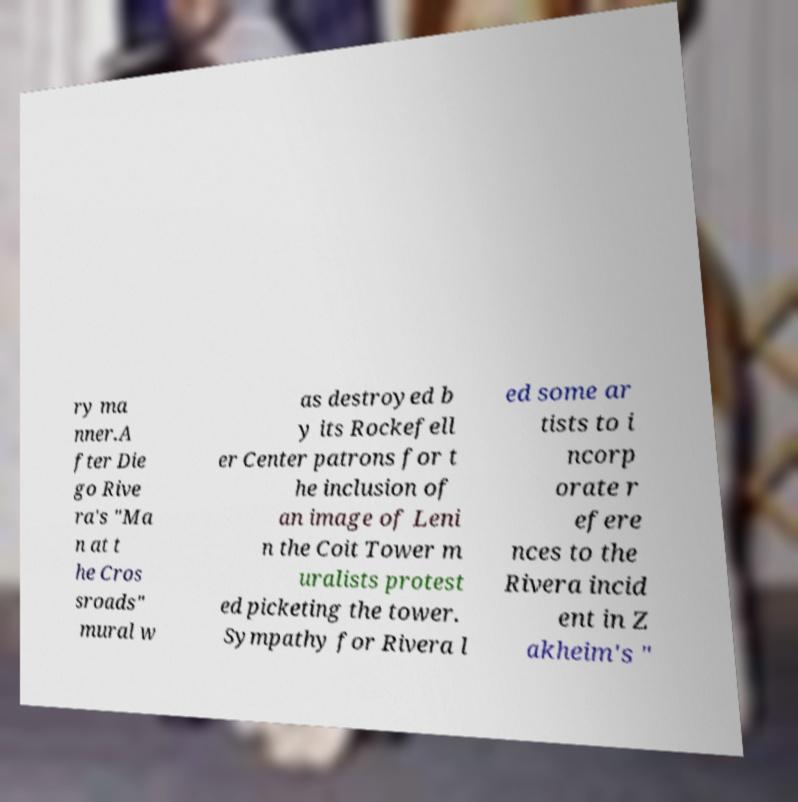I need the written content from this picture converted into text. Can you do that? ry ma nner.A fter Die go Rive ra's "Ma n at t he Cros sroads" mural w as destroyed b y its Rockefell er Center patrons for t he inclusion of an image of Leni n the Coit Tower m uralists protest ed picketing the tower. Sympathy for Rivera l ed some ar tists to i ncorp orate r efere nces to the Rivera incid ent in Z akheim's " 